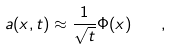Convert formula to latex. <formula><loc_0><loc_0><loc_500><loc_500>a ( x , t ) \approx \frac { 1 } { \sqrt { t } } \Phi ( x ) \quad ,</formula> 